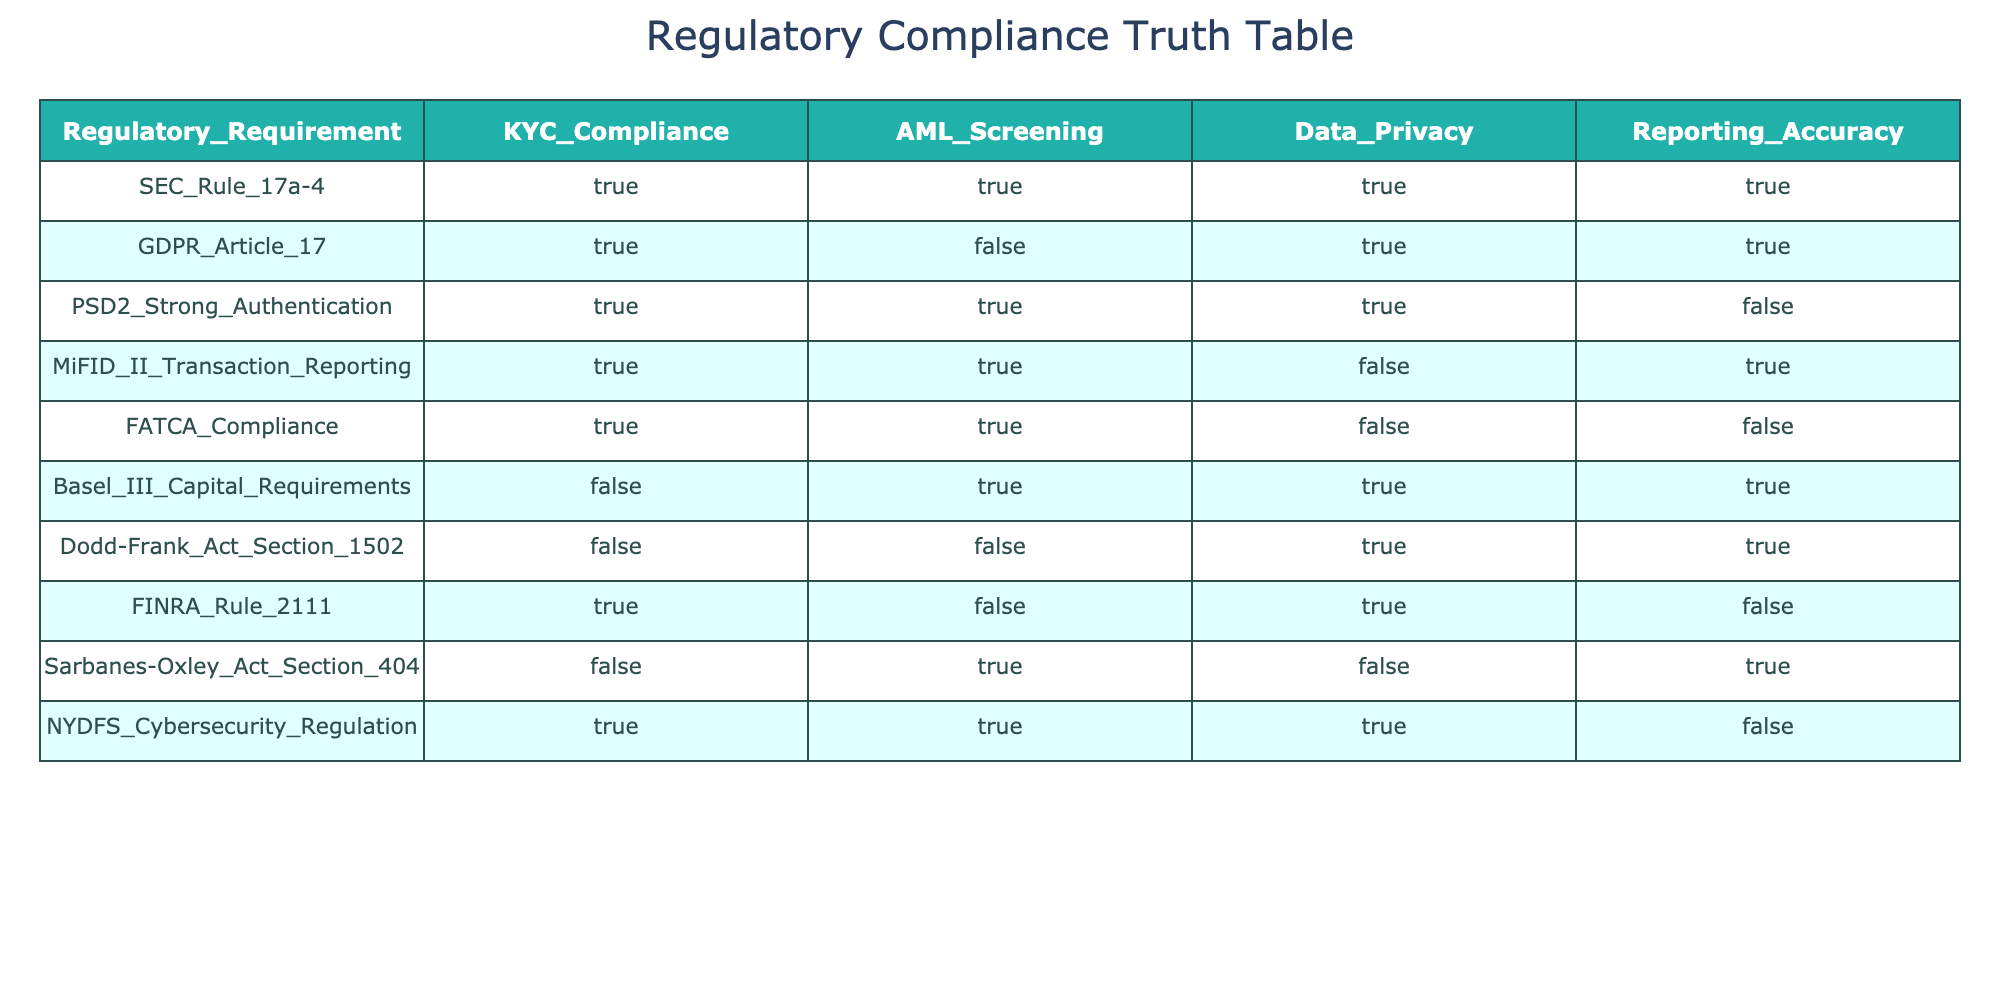What regulatory requirements comply with both KYC and AML? Looking at the table, the regulatory requirements that have both KYC and AML compliance marked as TRUE are SEC Rule 17a-4, PSD2 Strong Authentication, MiFID II Transaction Reporting, FATCA Compliance, and NYDFS Cybersecurity Regulation.
Answer: SEC Rule 17a-4, PSD2 Strong Authentication, MiFID II Transaction Reporting, FATCA Compliance, NYDFS Cybersecurity Regulation Which regulatory requirement has the highest number of compliance flags (TRUE values)? By examining each row, we can see that SEC Rule 17a-4, GDPR Article 17, and NYDFS Cybersecurity Regulation have 4 compliance flags marked as TRUE. The others have fewer.
Answer: SEC Rule 17a-4, GDPR Article 17, NYDFS Cybersecurity Regulation Is there any regulatory requirement that complies with Data Privacy but fails KYC and AML? Checking the table, we see that Dodd-Frank Act Section 1502 has Data Privacy marked as TRUE while both KYC and AML compliance are marked as FALSE.
Answer: Yes How many regulatory requirements do not meet the reporting accuracy standard? By reviewing each row in the Reporting Accuracy column, we find that PSD2 Strong Authentication, FATCA Compliance, and FINRA Rule 2111 have FALSE in Reporting Accuracy, totaling 3 such requirements.
Answer: 3 Which regulatory requirements have at least one compliance flag marked as FALSE? Analyzing the entire table, the regulatory requirements that have at least one FALSE value are GDPR Article 17, PSD2 Strong Authentication, FATCA Compliance, Basel III Capital Requirements, Dodd-Frank Act Section 1502, FINRA Rule 2111, and Sarbanes-Oxley Act Section 404.
Answer: GDPR Article 17, PSD2 Strong Authentication, FATCA Compliance, Basel III Capital Requirements, Dodd-Frank Act Section 1502, FINRA Rule 2111, Sarbanes-Oxley Act Section 404 Are there any regulatory requirements that comply with ALL standards? Looking at the table, the only regulatory requirement that complies with all standards (KYC, AML, Data Privacy, and Reporting Accuracy) is SEC Rule 17a-4.
Answer: Yes, SEC Rule 17a-4 What is the total number of TRUE compliance flags across all regulatory requirements? To find this, we count all the TRUE values in the KYC Compliance, AML Screening, Data Privacy, and Reporting Accuracy columns. There are a total of 11 TRUE values in the table.
Answer: 11 How many requirements comply with AML but not KYC? By looking at the table, we find that there are 2 cases: Basel III Capital Requirements and Dodd-Frank Act Section 1502 where AML is TRUE while KYC is FALSE.
Answer: 2 